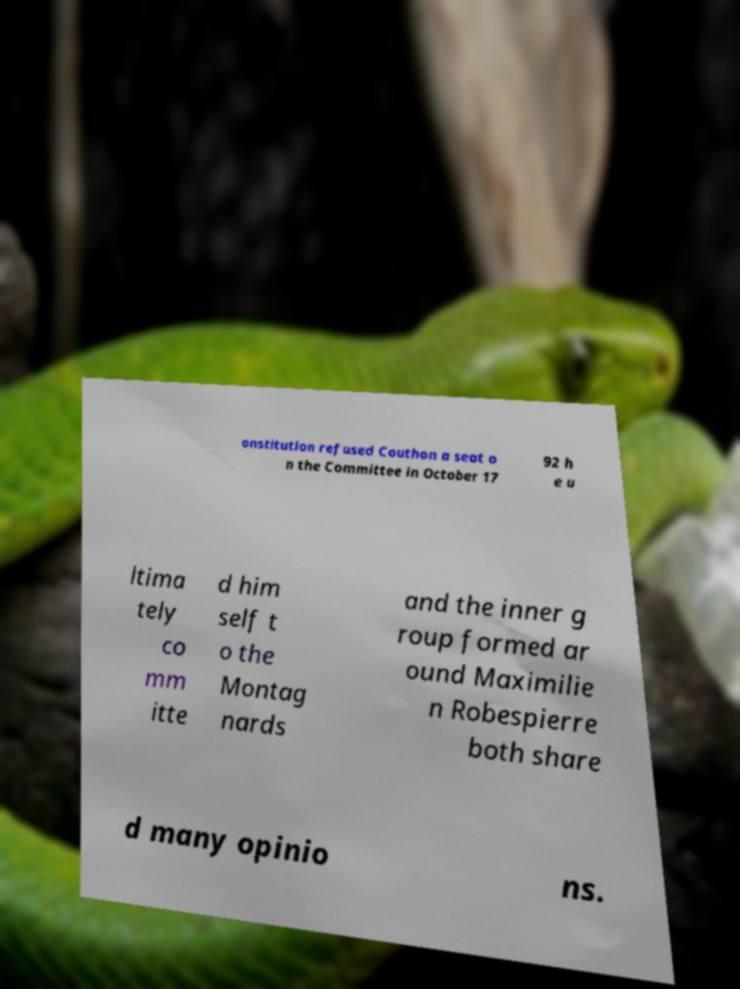Please read and relay the text visible in this image. What does it say? onstitution refused Couthon a seat o n the Committee in October 17 92 h e u ltima tely co mm itte d him self t o the Montag nards and the inner g roup formed ar ound Maximilie n Robespierre both share d many opinio ns. 